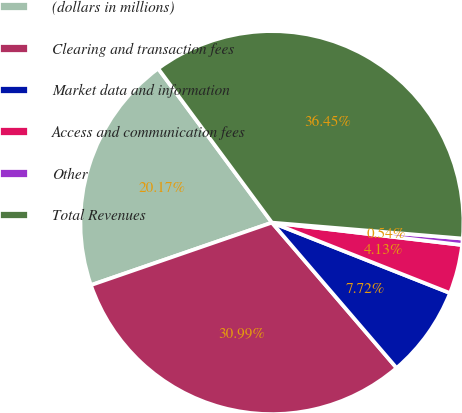Convert chart. <chart><loc_0><loc_0><loc_500><loc_500><pie_chart><fcel>(dollars in millions)<fcel>Clearing and transaction fees<fcel>Market data and information<fcel>Access and communication fees<fcel>Other<fcel>Total Revenues<nl><fcel>20.17%<fcel>30.99%<fcel>7.72%<fcel>4.13%<fcel>0.54%<fcel>36.45%<nl></chart> 